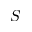<formula> <loc_0><loc_0><loc_500><loc_500>S</formula> 